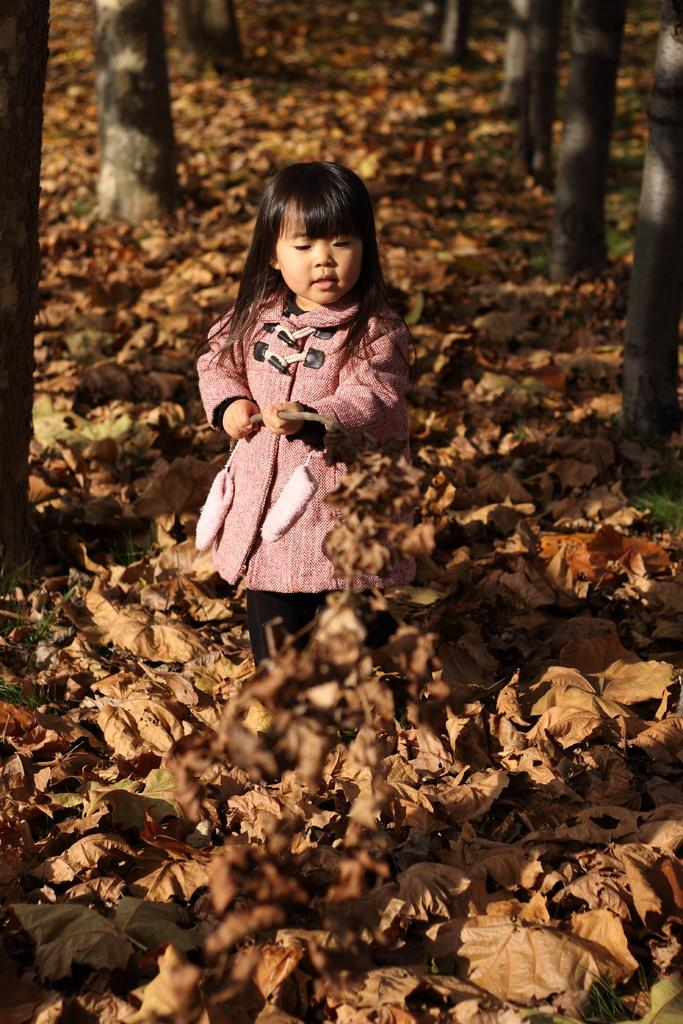What is the main subject of the image? There is a little cute girl in the image. Where is the girl positioned in the image? The girl is standing in the middle of the image. What type of natural elements can be seen in the image? There are dried leaves in the image. What statement is the girl making in the image? There is no statement visible in the image; it only shows the girl standing amidst dried leaves. How many flies can be seen in the image? There are no flies present in the image. 